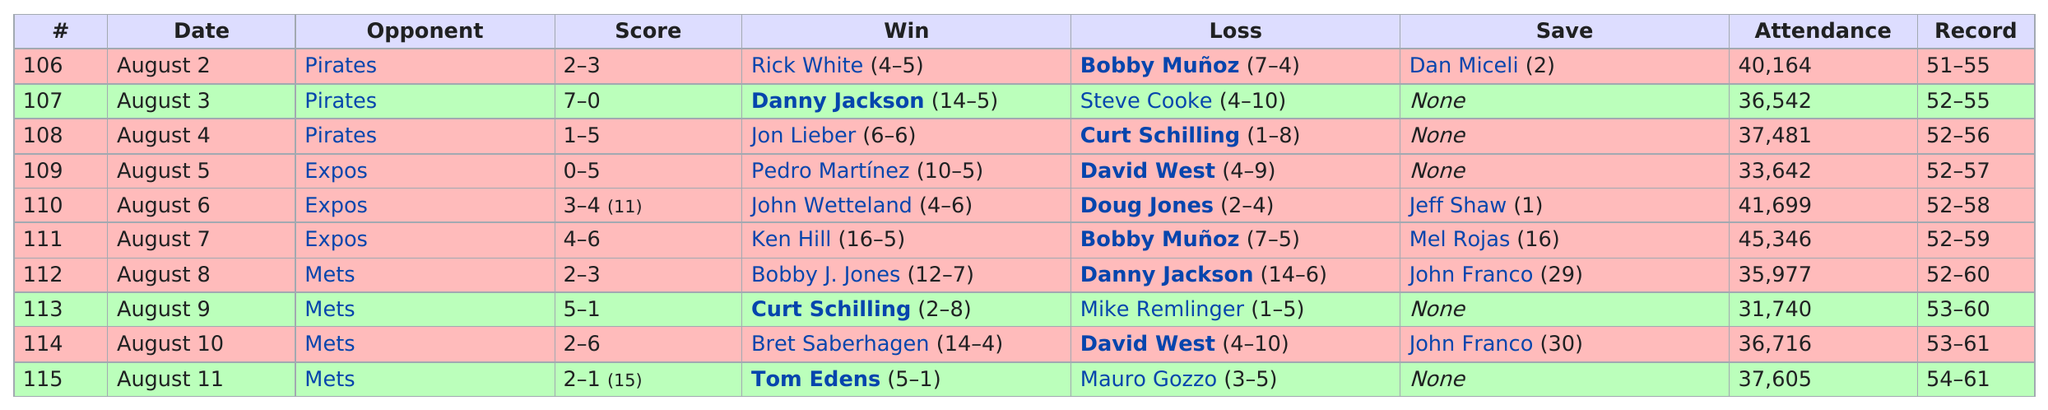Draw attention to some important aspects in this diagram. In the most recent encounter between the Philadelphia Phillies and the Montreal Expos, the final score was 4-6, indicating a close and competitive game between the two teams. Ken Hill achieved his win on August 7, 2023. The game with the lowest attendance was 113. After August 4, a total of two different opponents were played against. The attendance was above 40,000 for three games. 